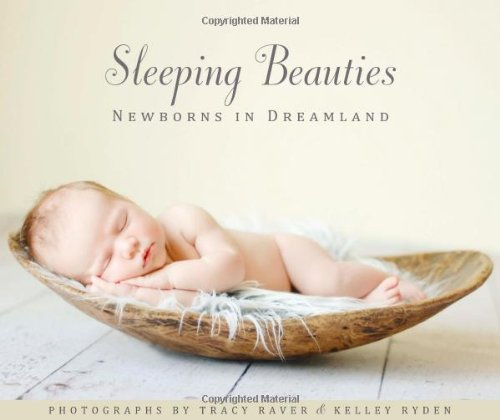Can this book be used as a guide for amateur photographers interested in newborn photography? Yes, while primarily an artistic showcase, 'Sleeping Beauties: Newborns in Dreamland' also serves as an inspirational guide for amateur photographers, offering insights into the composition, lighting, and styling techniques suitable for capturing the essence of newborns. 